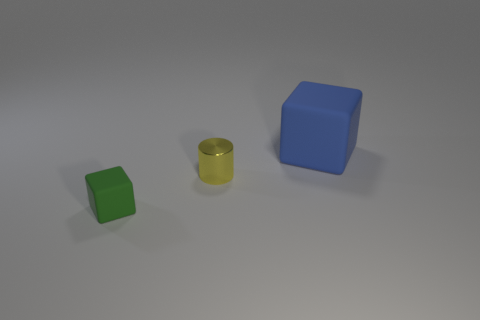Add 3 large cubes. How many objects exist? 6 Subtract all green cubes. How many cubes are left? 1 Subtract all cubes. How many objects are left? 1 Subtract 2 blocks. How many blocks are left? 0 Subtract all yellow metal cylinders. Subtract all rubber blocks. How many objects are left? 0 Add 1 blue cubes. How many blue cubes are left? 2 Add 1 small brown things. How many small brown things exist? 1 Subtract 1 green blocks. How many objects are left? 2 Subtract all blue blocks. Subtract all brown cylinders. How many blocks are left? 1 Subtract all cyan spheres. How many green cubes are left? 1 